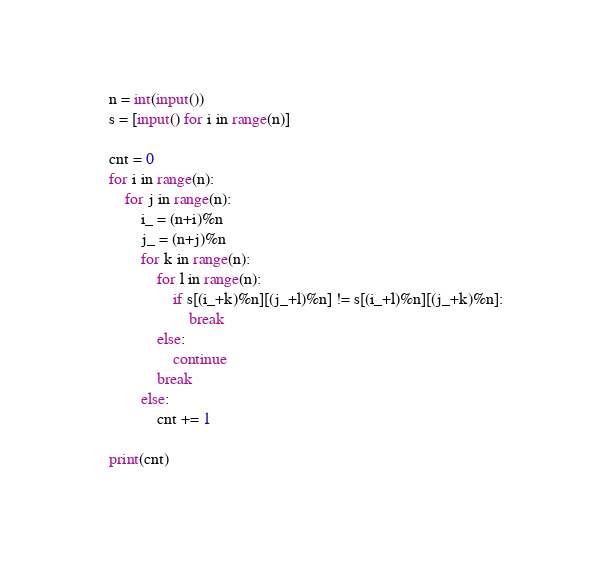<code> <loc_0><loc_0><loc_500><loc_500><_Python_>n = int(input())
s = [input() for i in range(n)]

cnt = 0
for i in range(n):
    for j in range(n):
        i_ = (n+i)%n
        j_ = (n+j)%n
        for k in range(n):
            for l in range(n):
                if s[(i_+k)%n][(j_+l)%n] != s[(i_+l)%n][(j_+k)%n]:
                    break
            else:
                continue
            break
        else:
            cnt += 1

print(cnt)</code> 